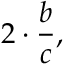Convert formula to latex. <formula><loc_0><loc_0><loc_500><loc_500>2 \cdot { \frac { b } { c } } ,</formula> 